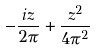<formula> <loc_0><loc_0><loc_500><loc_500>- \frac { i z } { 2 \pi } + \frac { z ^ { 2 } } { 4 \pi ^ { 2 } }</formula> 